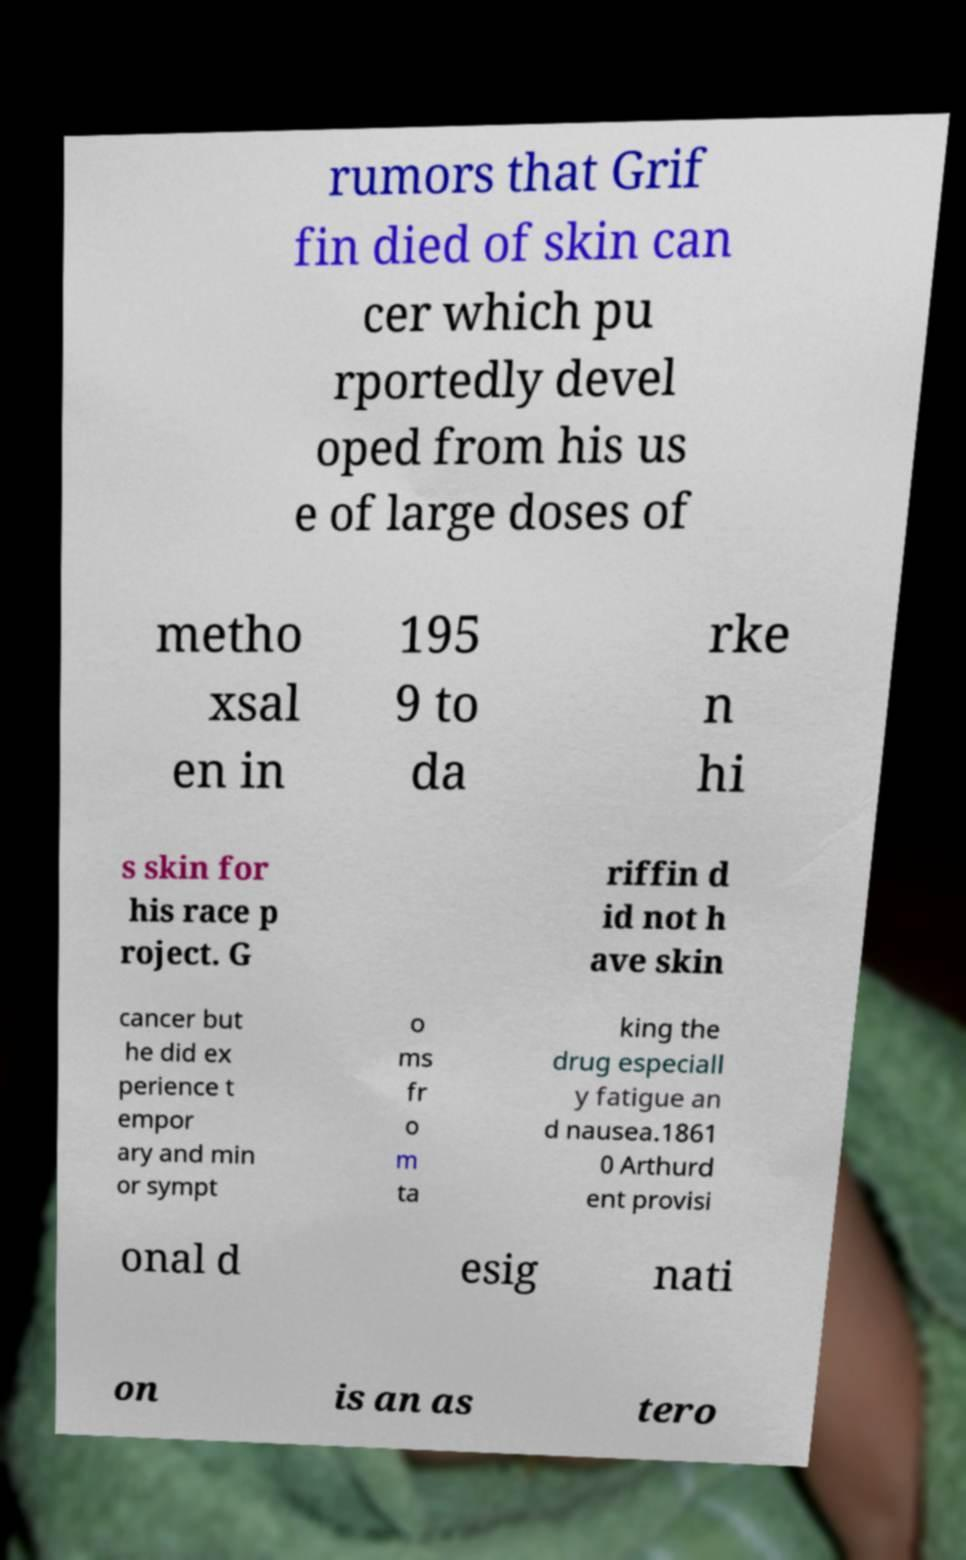Could you extract and type out the text from this image? rumors that Grif fin died of skin can cer which pu rportedly devel oped from his us e of large doses of metho xsal en in 195 9 to da rke n hi s skin for his race p roject. G riffin d id not h ave skin cancer but he did ex perience t empor ary and min or sympt o ms fr o m ta king the drug especiall y fatigue an d nausea.1861 0 Arthurd ent provisi onal d esig nati on is an as tero 